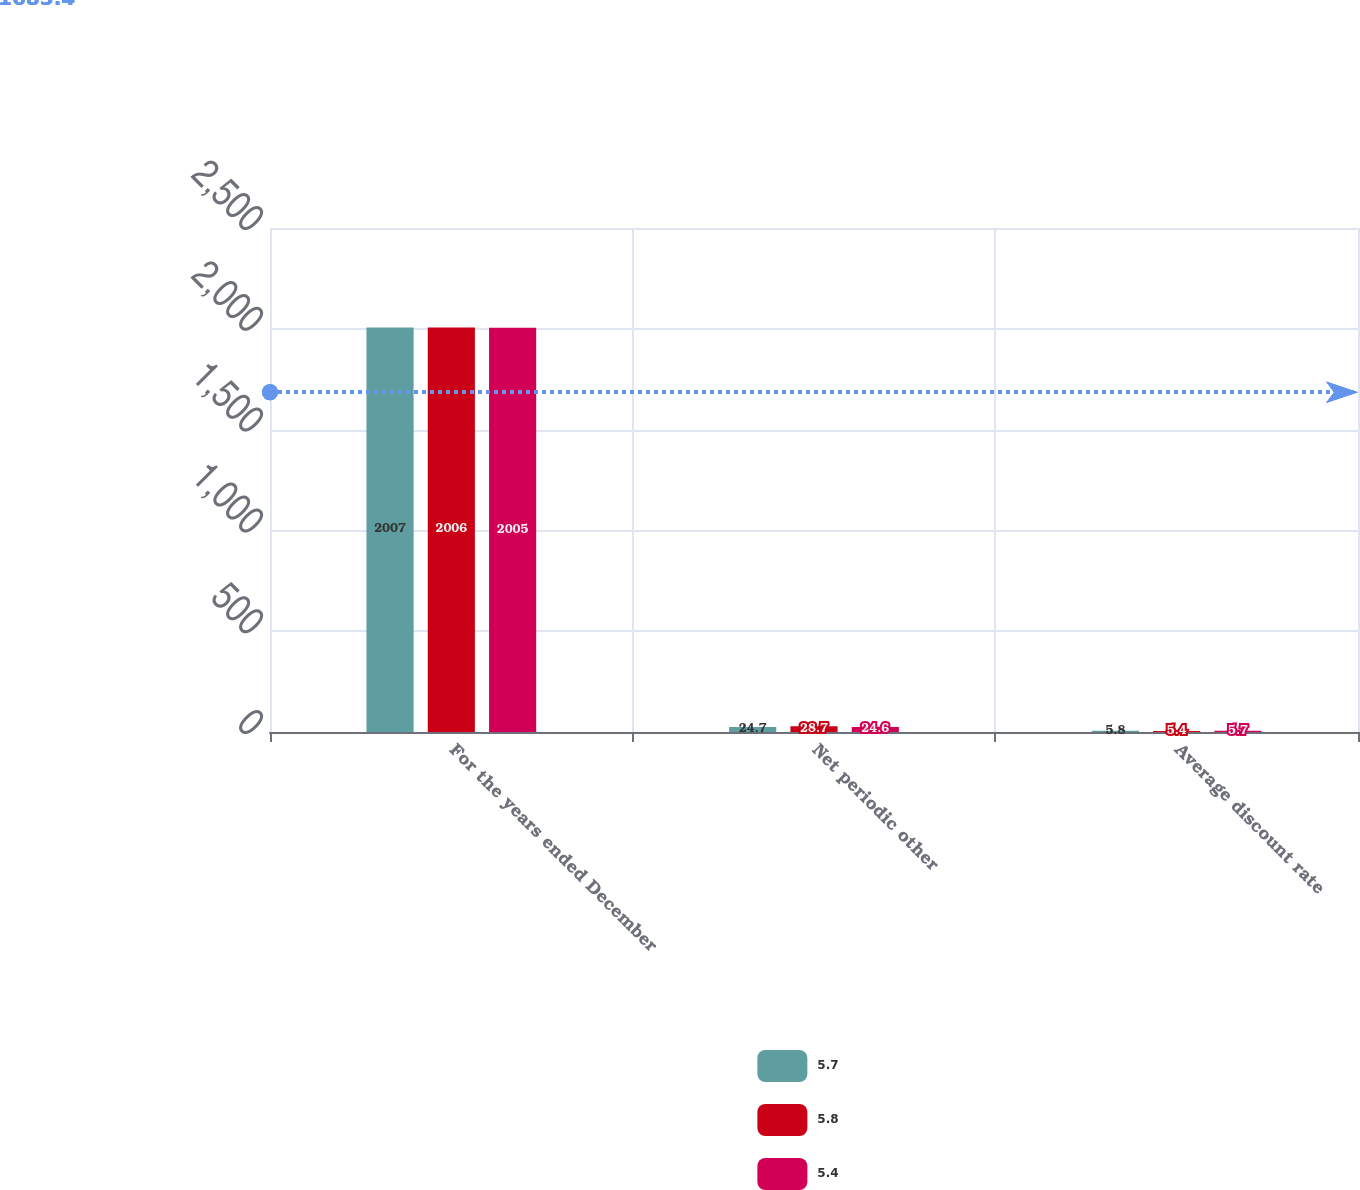Convert chart to OTSL. <chart><loc_0><loc_0><loc_500><loc_500><stacked_bar_chart><ecel><fcel>For the years ended December<fcel>Net periodic other<fcel>Average discount rate<nl><fcel>5.7<fcel>2007<fcel>24.7<fcel>5.8<nl><fcel>5.8<fcel>2006<fcel>28.7<fcel>5.4<nl><fcel>5.4<fcel>2005<fcel>24.6<fcel>5.7<nl></chart> 